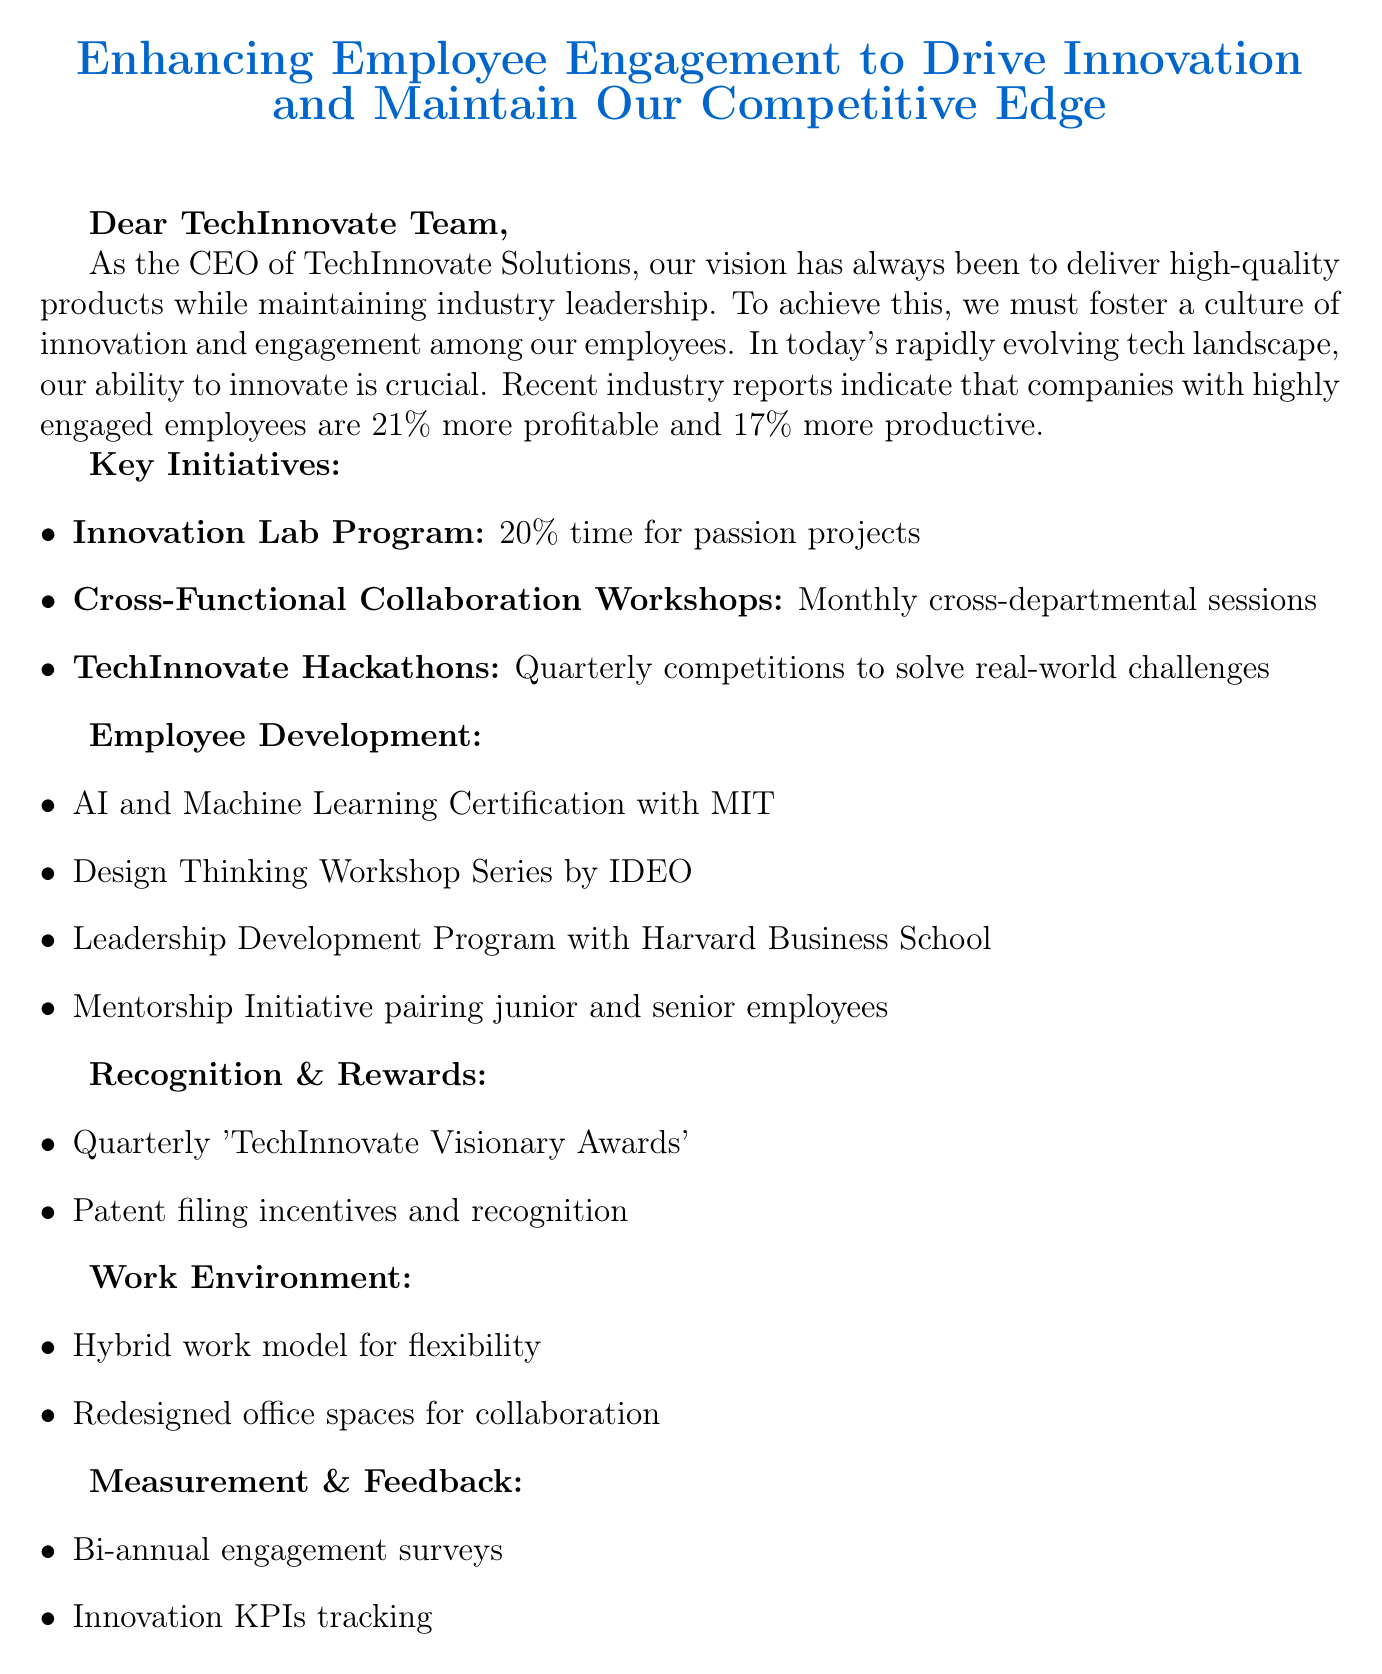What is the title of the memo? The title of the memo is explicitly mentioned at the beginning, stating the focus on employee engagement and innovation.
Answer: Enhancing Employee Engagement to Drive Innovation and Maintain Our Competitive Edge What is the first initiative mentioned in the memo? The first initiative is highlighted in the main initiatives section, focusing on the innovation lab program.
Answer: Innovation Lab Program How often will the cross-functional collaboration workshops be held? The frequency of the workshops is provided in the description of the initiative, specifying it occurs monthly.
Answer: Monthly What is the expected outcome of the TechInnovate Hackathons? The outcome is stated clearly in the initiative description, aiming to generate innovative solutions and identify talent.
Answer: Generate innovative solutions and identify top talent within the organization Who is leading the HR department responsible for the initiative rollout? The document states the leader's name in the conclusion, who will manage the upcoming plans for initiatives.
Answer: Sarah Johnson How many training programs are listed in the employee development section? The document lists the training programs explicitly, which can be counted in the employee development section.
Answer: Three What percentage of time can employees spend on their passion projects in the Innovation Lab Program? The percentage of time allocated for passion projects is directly mentioned in the initiative description.
Answer: 20% What is the purpose of conducting bi-annual employee engagement surveys? The purpose is stated in the measurement and feedback section, which aims at measuring the impact of initiatives.
Answer: Measure the impact of our initiatives 